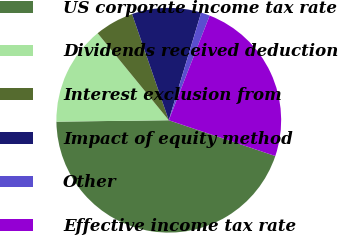Convert chart to OTSL. <chart><loc_0><loc_0><loc_500><loc_500><pie_chart><fcel>US corporate income tax rate<fcel>Dividends received deduction<fcel>Interest exclusion from<fcel>Impact of equity method<fcel>Other<fcel>Effective income tax rate<nl><fcel>44.64%<fcel>14.29%<fcel>5.61%<fcel>9.95%<fcel>1.28%<fcel>24.23%<nl></chart> 